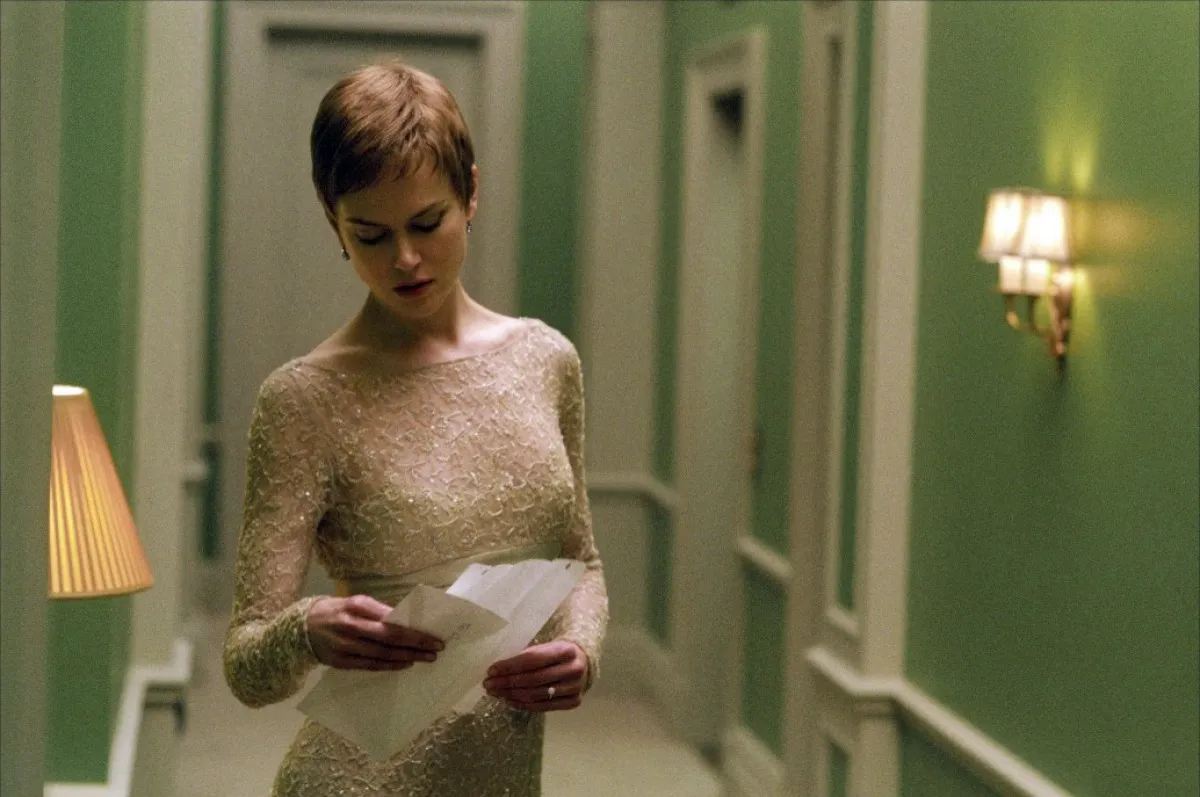Write a detailed description of the given image. The image depicts a woman with a short hair style, dressed in an elegant white lace dress, standing in a hallway with a serene green color scheme. She is gazing down at a document in her hands, with a focused and contemplative expression. The environment features a classic decor with green doors and a lit wall lamp that provides a warm ambiance. The scene conveys a mood of quiet introspection or decision-making. 